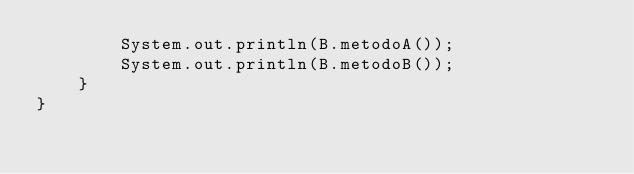<code> <loc_0><loc_0><loc_500><loc_500><_Java_>        System.out.println(B.metodoA());
        System.out.println(B.metodoB());
    }
}
</code> 